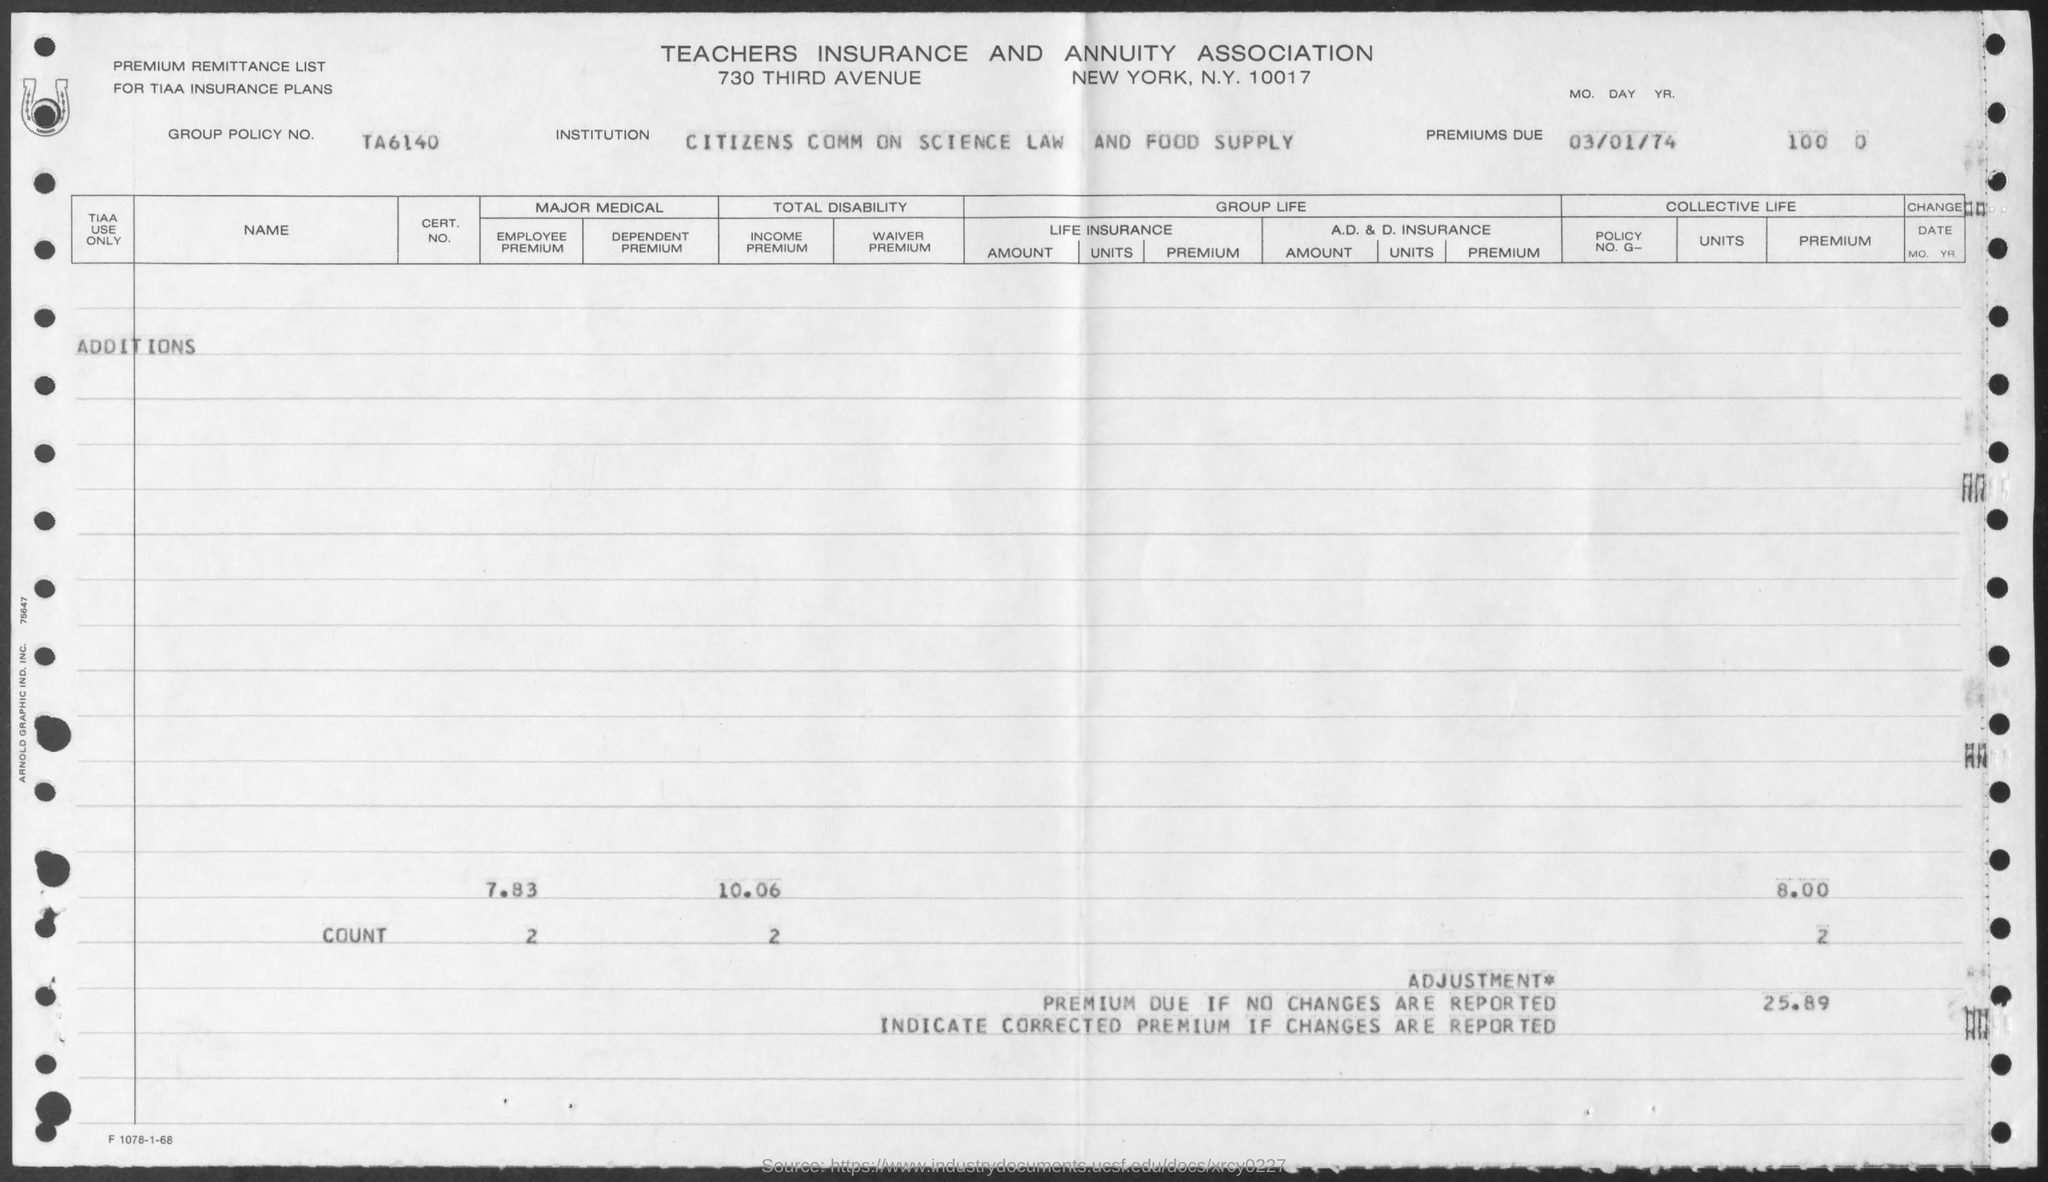What is the group policy no ?
Provide a short and direct response. TA6140. What is the date mentioned ?
Make the answer very short. 03/01/74. What is the name of the institution
Offer a very short reply. CITIZENS COMM ON SCIENCE LAW AND FOOD SUPPLY. 